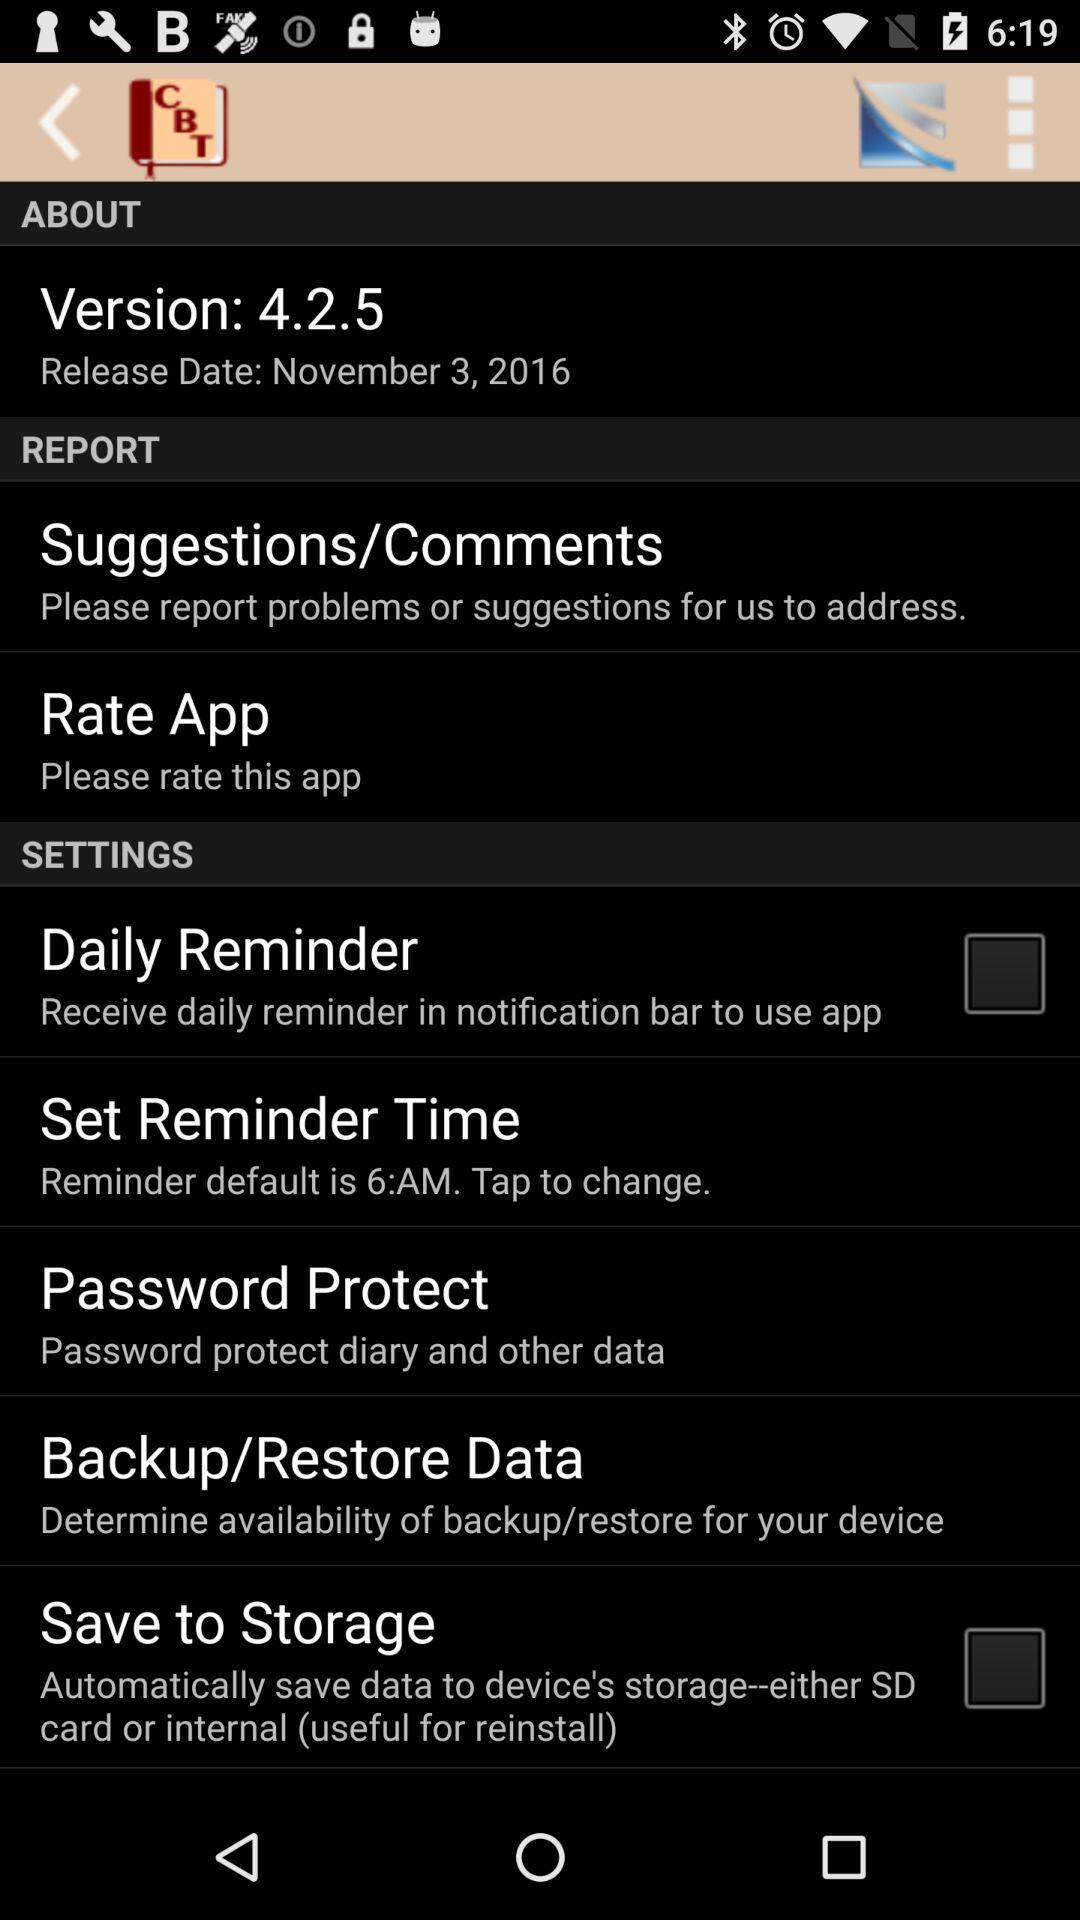What is the version of the application? The version is 4.2.5. 